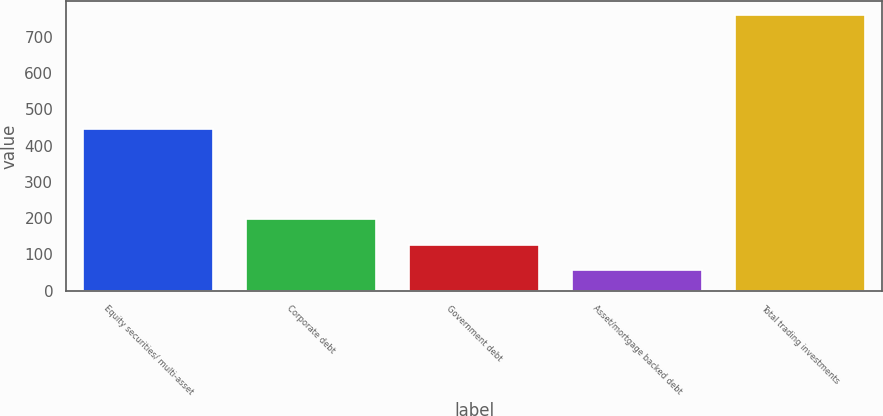Convert chart to OTSL. <chart><loc_0><loc_0><loc_500><loc_500><bar_chart><fcel>Equity securities/ multi-asset<fcel>Corporate debt<fcel>Government debt<fcel>Asset/mortgage backed debt<fcel>Total trading investments<nl><fcel>446<fcel>196.8<fcel>126.4<fcel>56<fcel>760<nl></chart> 